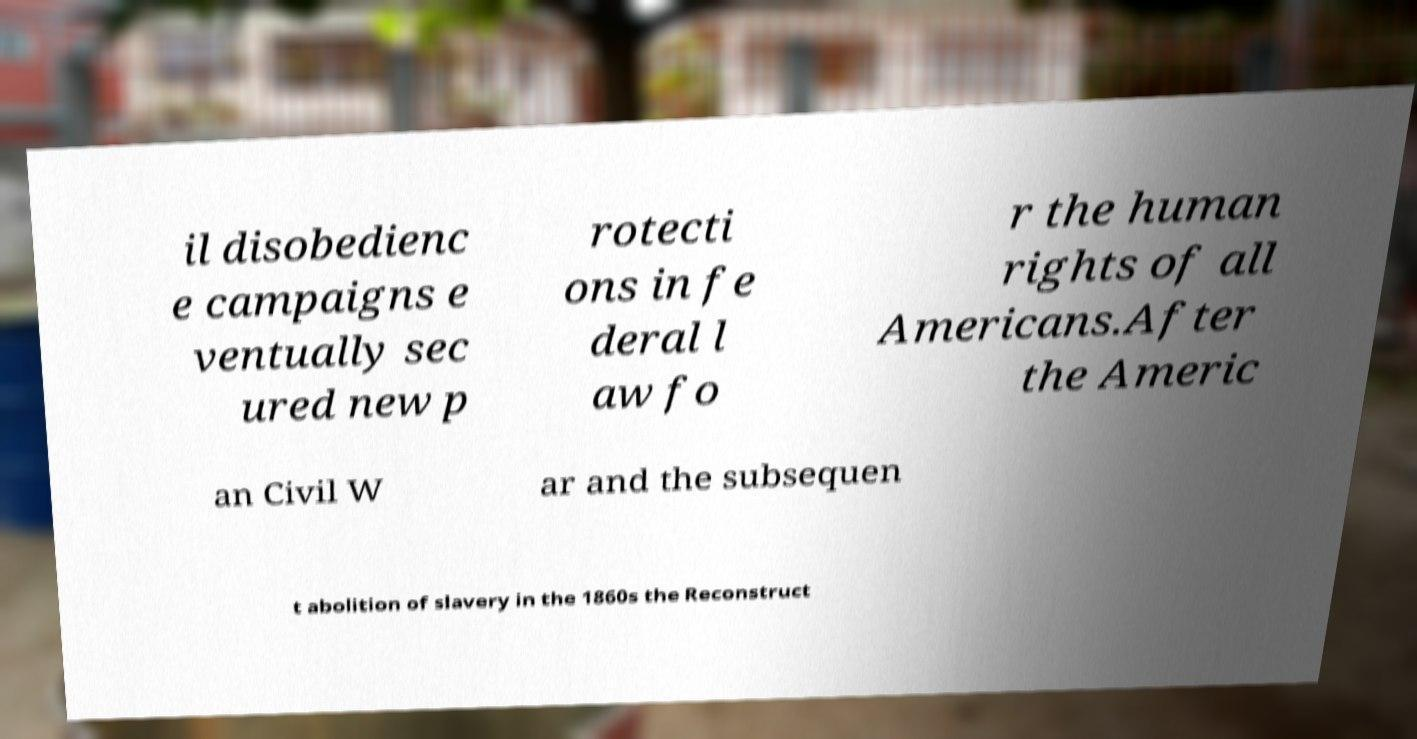Can you accurately transcribe the text from the provided image for me? il disobedienc e campaigns e ventually sec ured new p rotecti ons in fe deral l aw fo r the human rights of all Americans.After the Americ an Civil W ar and the subsequen t abolition of slavery in the 1860s the Reconstruct 